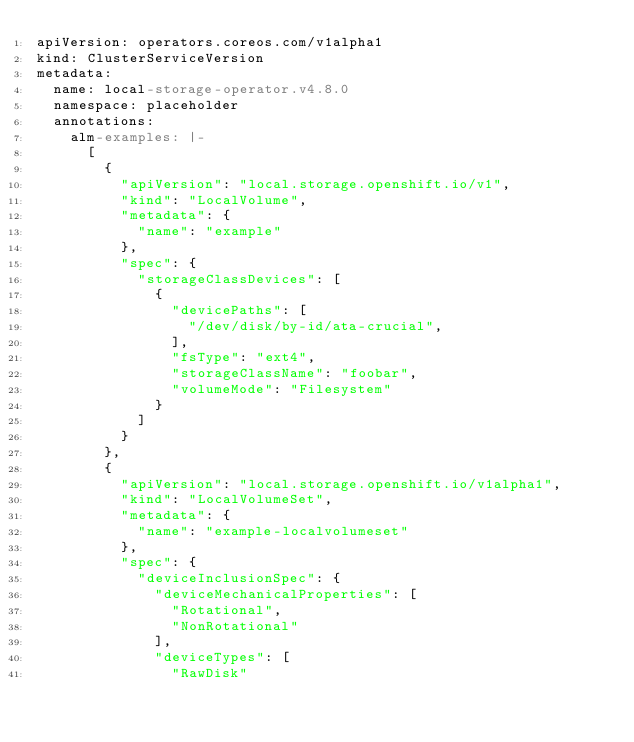Convert code to text. <code><loc_0><loc_0><loc_500><loc_500><_YAML_>apiVersion: operators.coreos.com/v1alpha1
kind: ClusterServiceVersion
metadata:
  name: local-storage-operator.v4.8.0
  namespace: placeholder
  annotations:
    alm-examples: |-
      [
        {
          "apiVersion": "local.storage.openshift.io/v1",
          "kind": "LocalVolume",
          "metadata": {
            "name": "example"
          },
          "spec": {
            "storageClassDevices": [
              {
                "devicePaths": [
                  "/dev/disk/by-id/ata-crucial",
                ],
                "fsType": "ext4",
                "storageClassName": "foobar",
                "volumeMode": "Filesystem"
              }
            ]
          }
        },
        {
          "apiVersion": "local.storage.openshift.io/v1alpha1",
          "kind": "LocalVolumeSet",
          "metadata": {
            "name": "example-localvolumeset"
          },
          "spec": {
            "deviceInclusionSpec": {
              "deviceMechanicalProperties": [
                "Rotational",
                "NonRotational"
              ],
              "deviceTypes": [
                "RawDisk"</code> 